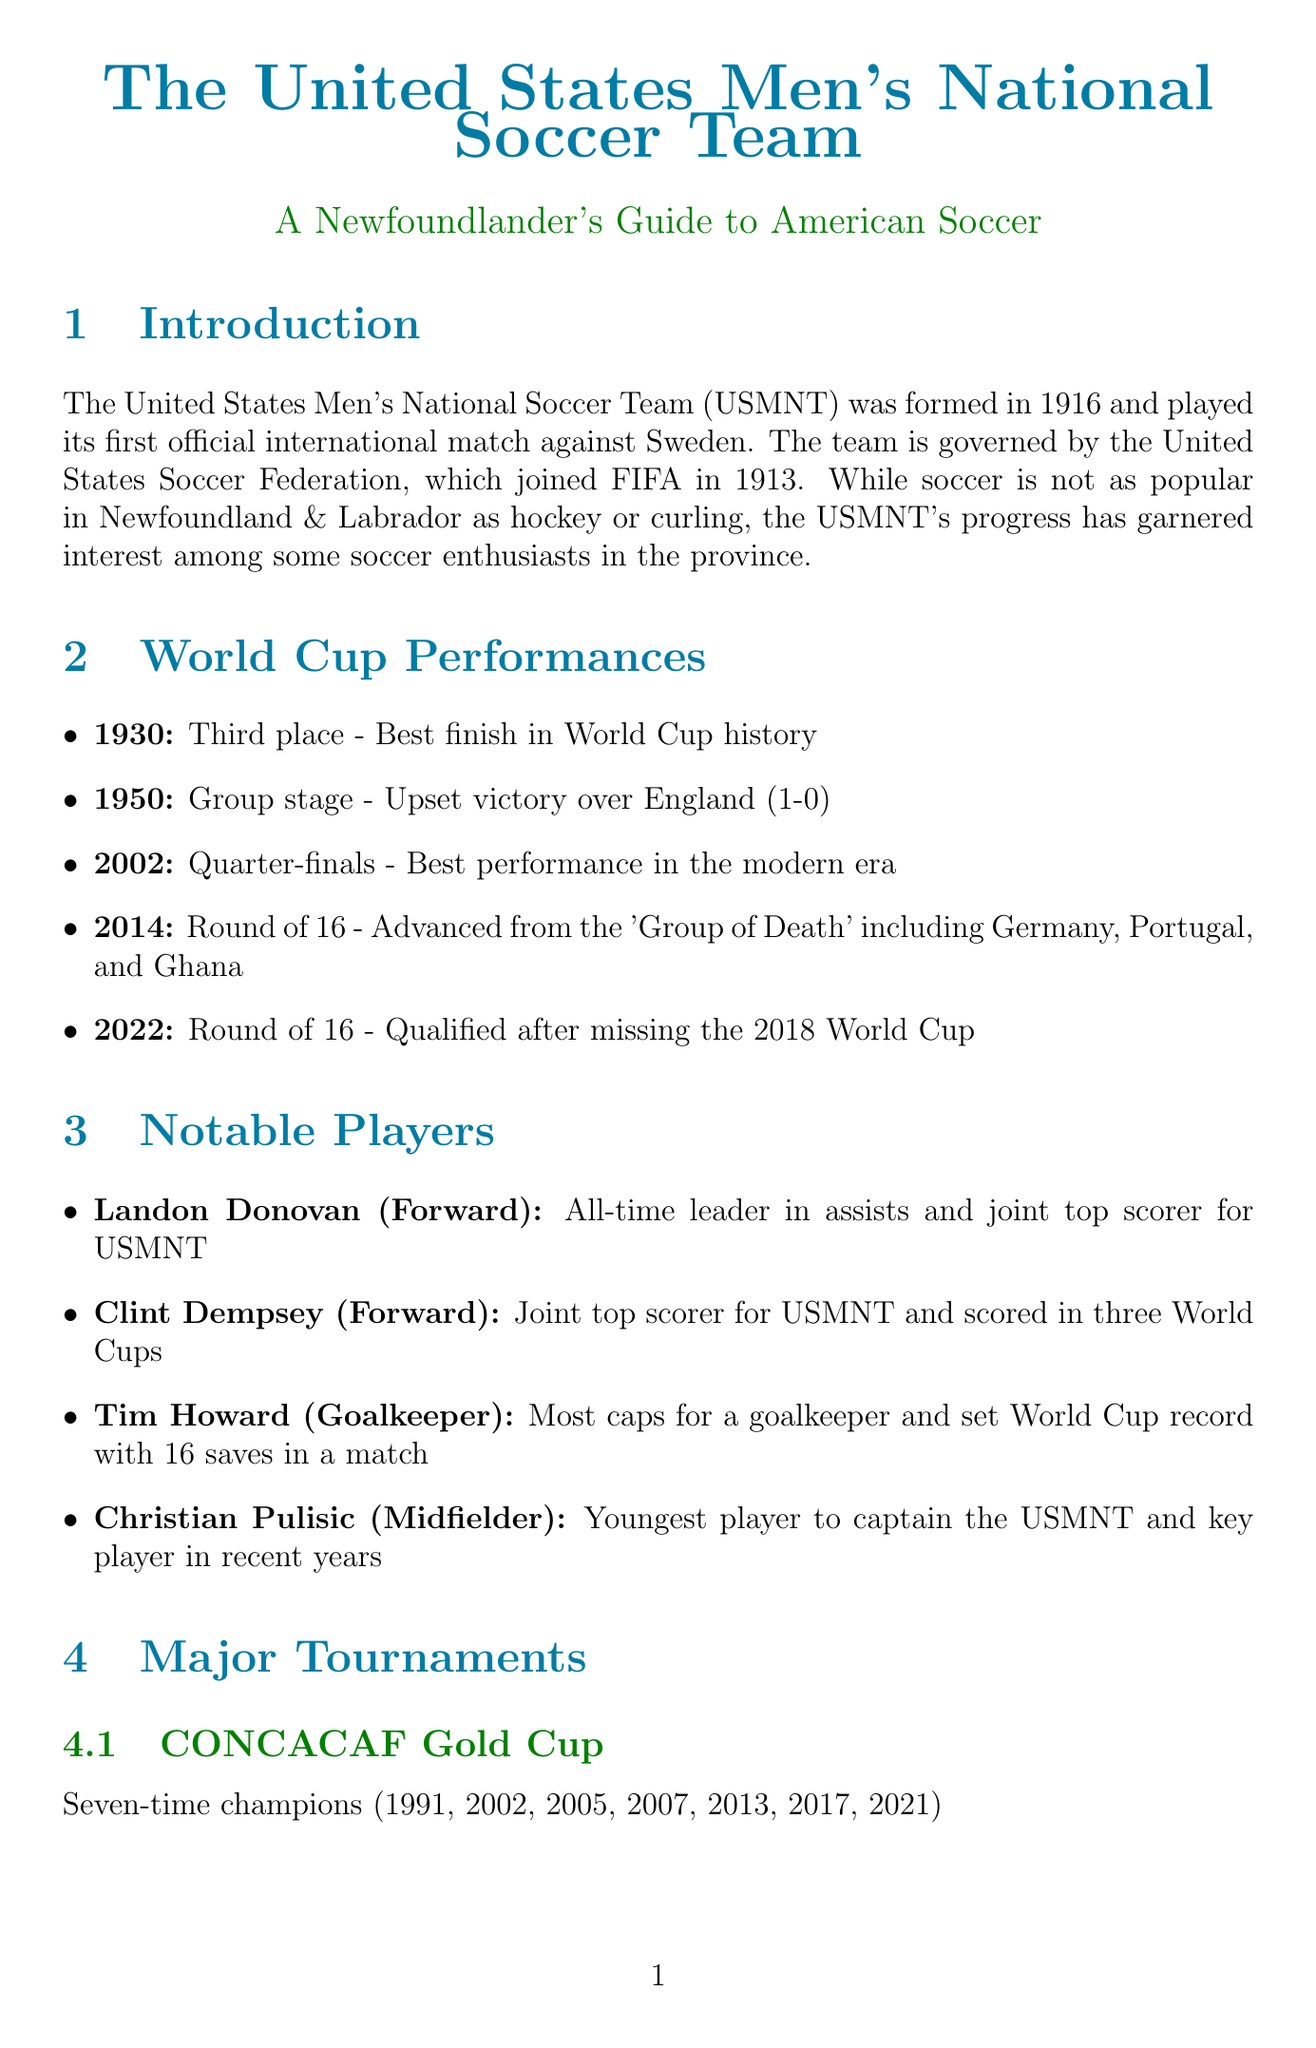What year was the USMNT formed? The document states that the USMNT was formed in 1916.
Answer: 1916 Which notable player is an all-time leader in assists? The document mentions Landon Donovan as the all-time leader in assists for the USMNT.
Answer: Landon Donovan How many times has the USMNT won the CONCACAF Gold Cup? According to the document, the USMNT has won the CONCACAF Gold Cup seven times.
Answer: Seven What was the USMNT's best finish in World Cup history? The document indicates that the best finish was third place in 1930.
Answer: Third place Who was the head coach of the USMNT appointed in 2018? The document states that Gregg Berhalter was appointed as head coach in 2018.
Answer: Gregg Berhalter In what year did the USMNT achieve an upset victory over England? The document mentions that the upset victory over England occurred in 1950.
Answer: 1950 What major tournament did the USMNT participate in 2026? The document notes that the USMNT will co-host the FIFA World Cup in 2026.
Answer: FIFA World Cup Which young player is highlighted as a key player in recent years? The document highlights Christian Pulisic as a key player in recent years.
Answer: Christian Pulisic What remarkable achievement did Tim Howard accomplish during a World Cup? The document states that Tim Howard set a World Cup record with 16 saves in a match.
Answer: 16 saves 